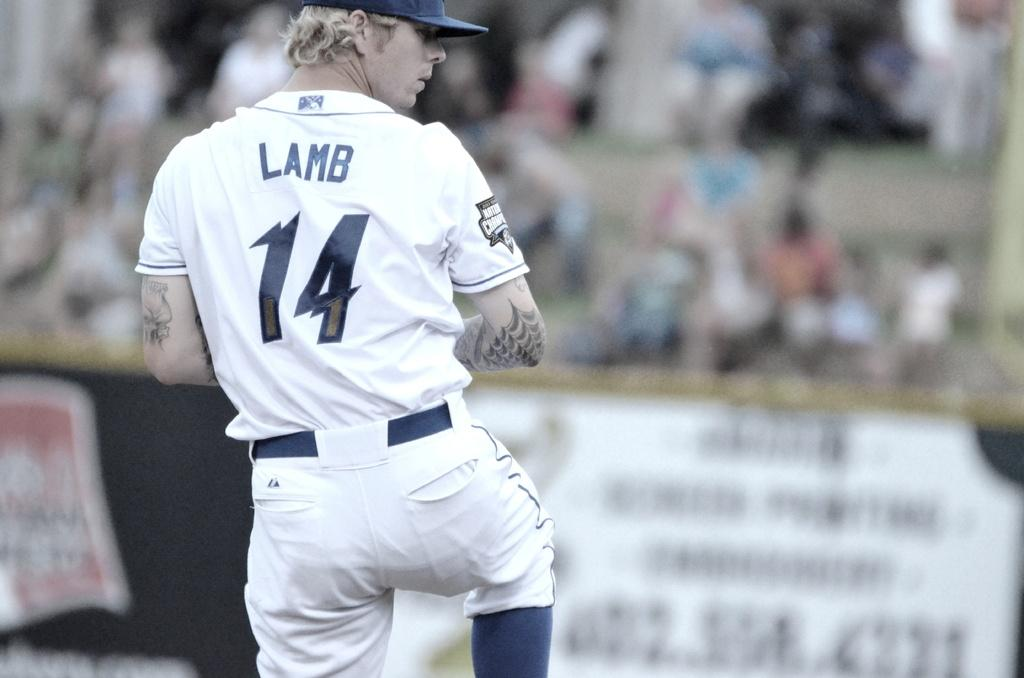Provide a one-sentence caption for the provided image. A baseball player with Lamb 14 on the back of his shirt. 